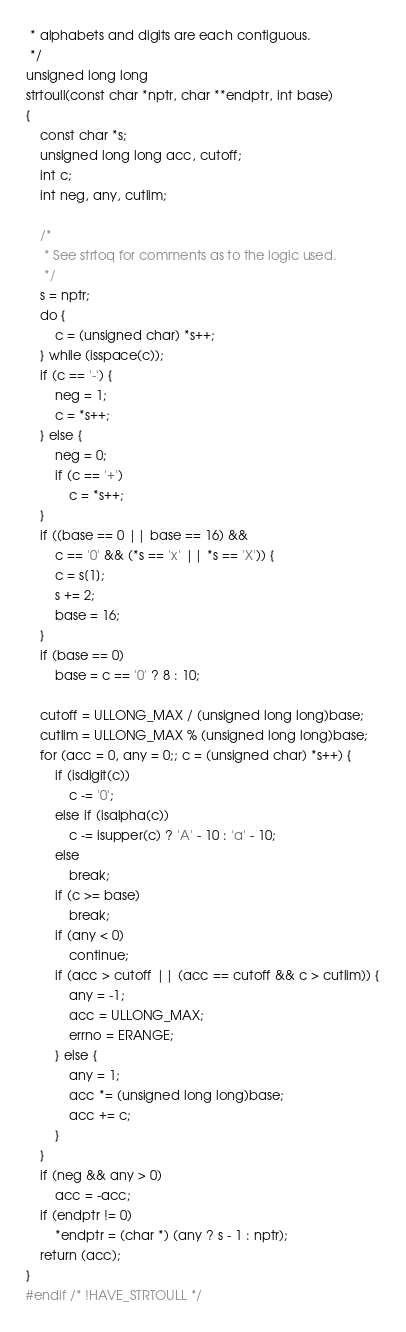<code> <loc_0><loc_0><loc_500><loc_500><_C_> * alphabets and digits are each contiguous.
 */
unsigned long long
strtoull(const char *nptr, char **endptr, int base)
{
	const char *s;
	unsigned long long acc, cutoff;
	int c;
	int neg, any, cutlim;

	/*
	 * See strtoq for comments as to the logic used.
	 */
	s = nptr;
	do {
		c = (unsigned char) *s++;
	} while (isspace(c));
	if (c == '-') {
		neg = 1;
		c = *s++;
	} else { 
		neg = 0;
		if (c == '+')
			c = *s++;
	}
	if ((base == 0 || base == 16) &&
	    c == '0' && (*s == 'x' || *s == 'X')) {
		c = s[1];
		s += 2;
		base = 16;
	}
	if (base == 0)
		base = c == '0' ? 8 : 10;

	cutoff = ULLONG_MAX / (unsigned long long)base;
	cutlim = ULLONG_MAX % (unsigned long long)base;
	for (acc = 0, any = 0;; c = (unsigned char) *s++) {
		if (isdigit(c))
			c -= '0';
		else if (isalpha(c))
			c -= isupper(c) ? 'A' - 10 : 'a' - 10;
		else
			break;
		if (c >= base)
			break;
		if (any < 0)
			continue;
		if (acc > cutoff || (acc == cutoff && c > cutlim)) {
			any = -1;
			acc = ULLONG_MAX;
			errno = ERANGE;
		} else {
			any = 1;
			acc *= (unsigned long long)base;
			acc += c;
		}
	}
	if (neg && any > 0)
		acc = -acc;
	if (endptr != 0)
		*endptr = (char *) (any ? s - 1 : nptr);
	return (acc);
}
#endif /* !HAVE_STRTOULL */
</code> 